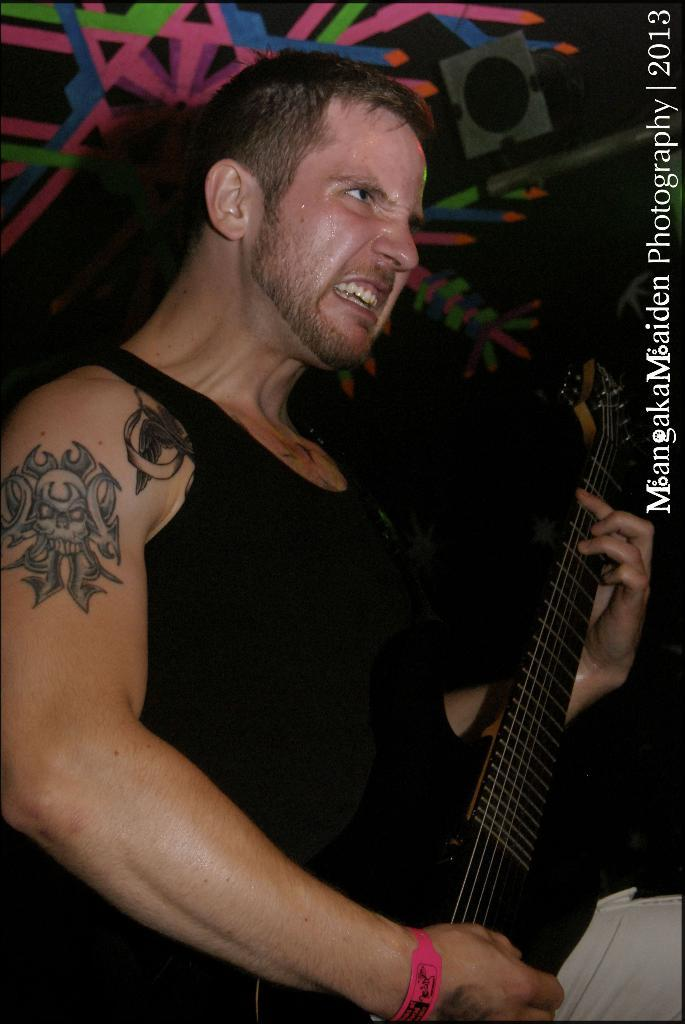What is the main subject of the picture? The main subject of the picture is a man. What is the man doing in the picture? The man is standing in the picture. What is the man holding in the picture? The man is holding a music instrument in the picture. What is the color of the music instrument? The music instrument is black in color. What type of silk fabric is draped over the man's shoulder in the image? There is no silk fabric present in the image. How many nails are visible on the man's hand in the image? There are no nails visible on the man's hand in the image. 